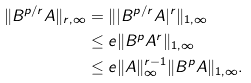Convert formula to latex. <formula><loc_0><loc_0><loc_500><loc_500>\| B ^ { p / r } A \| _ { r , \infty } & = \| | B ^ { p / r } A | ^ { r } \| _ { 1 , \infty } \\ & \leq e \| B ^ { p } A ^ { r } \| _ { 1 , \infty } \\ & \leq e \| A \| _ { \infty } ^ { r - 1 } \| B ^ { p } A \| _ { 1 , \infty } .</formula> 